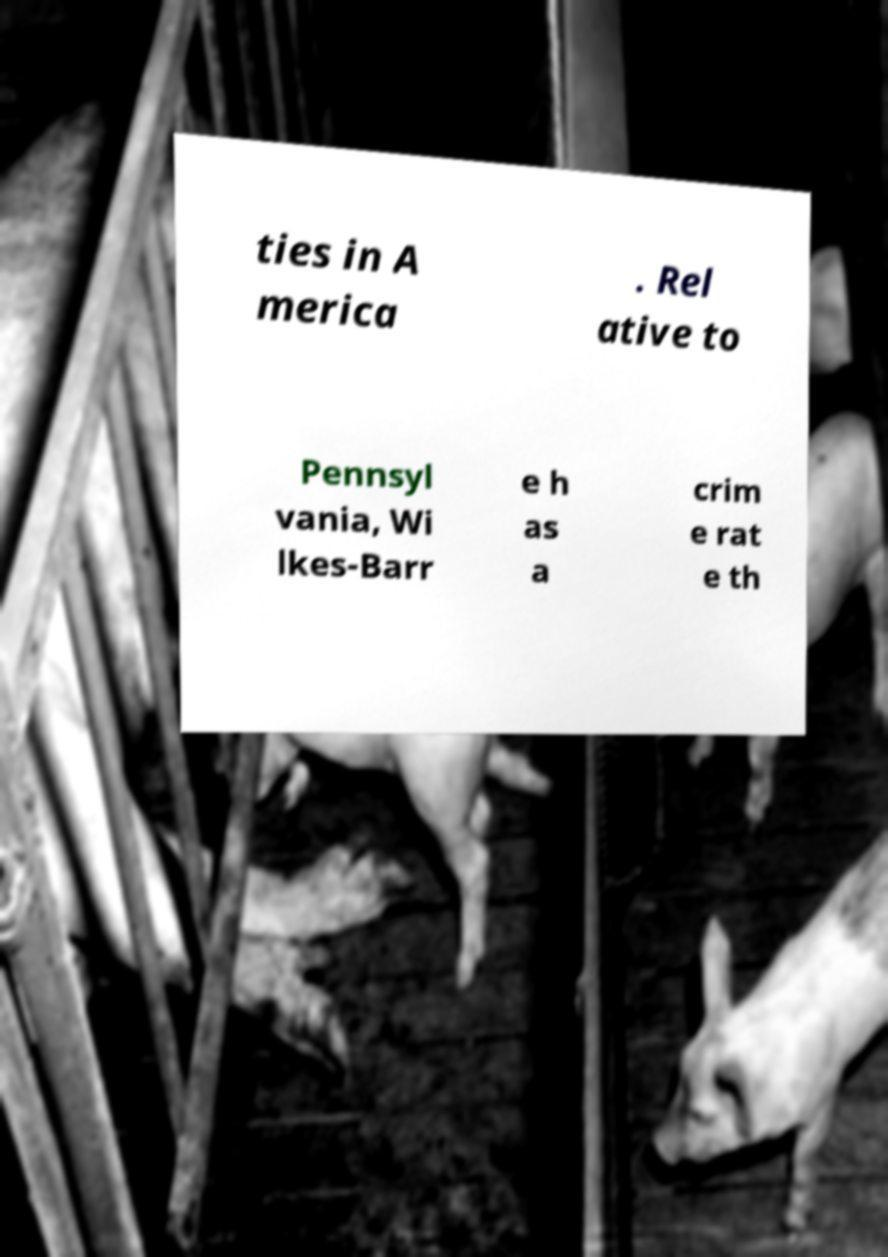Could you extract and type out the text from this image? ties in A merica . Rel ative to Pennsyl vania, Wi lkes-Barr e h as a crim e rat e th 